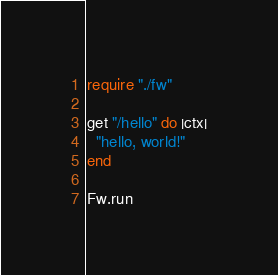Convert code to text. <code><loc_0><loc_0><loc_500><loc_500><_Crystal_>require "./fw"

get "/hello" do |ctx|
  "hello, world!"
end

Fw.run</code> 